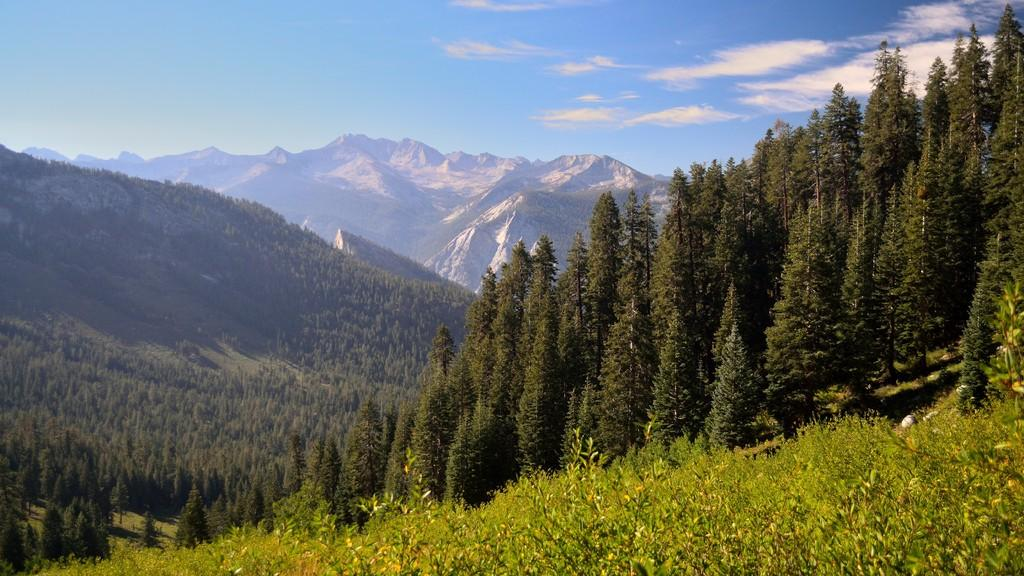What type of vegetation can be seen in the image? There are trees in the image. What is the color of the trees in the image? The trees are green in color. Where are the trees located in relation to the ground? The trees are on the ground. What can be seen in the background of the image? There are mountains and the sky visible in the background of the image. Are there trees on the mountains as well? Yes, there are trees on the mountains. What is visible in the sky in the image? The sky is visible in the background of the image. What is the weight of the air in the image? There is no specific weight of the air mentioned or depicted in the image, as air is not a tangible object that can have a measurable weight in this context. 